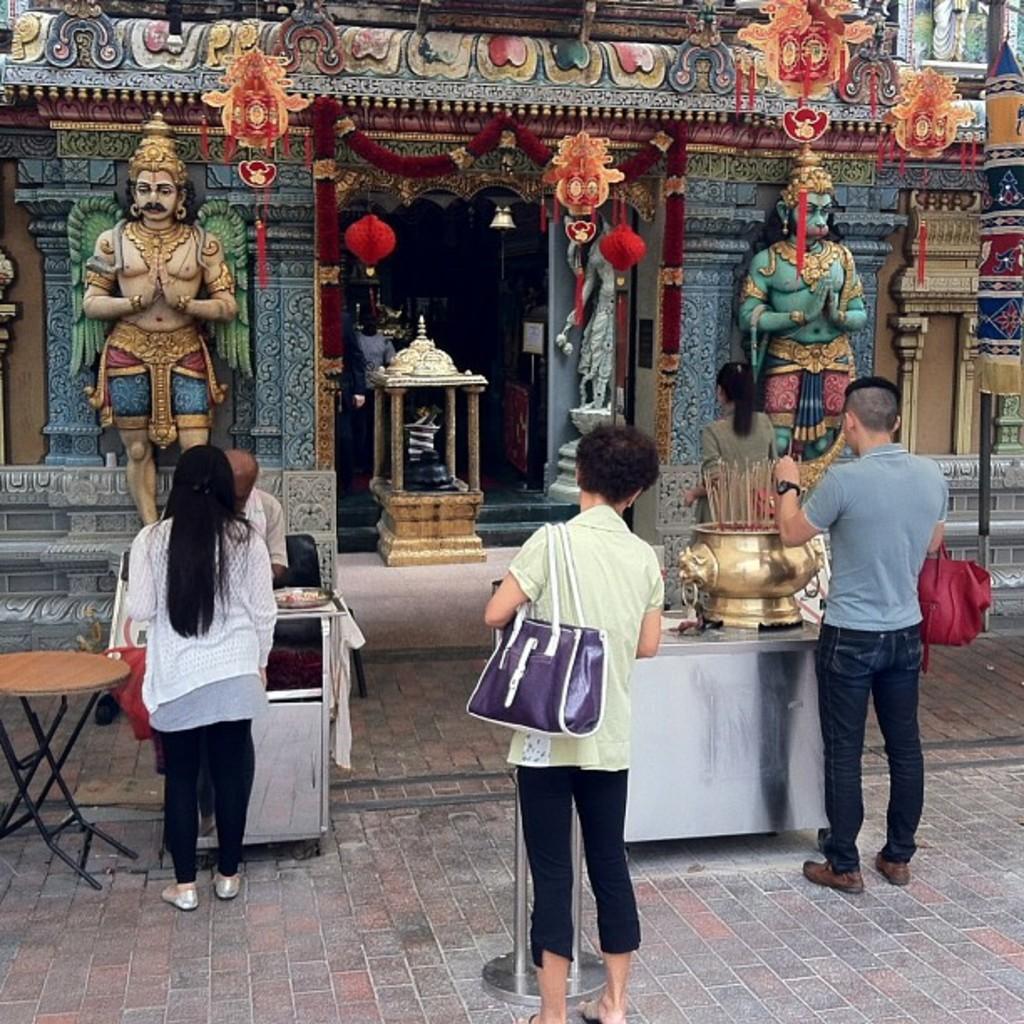In one or two sentences, can you explain what this image depicts? In this picture we can see a group of people standing carrying their bags in their hands and here person touching sticks and beside to them we have table and in front of them we can see a temple with sculptures and statues in it. 